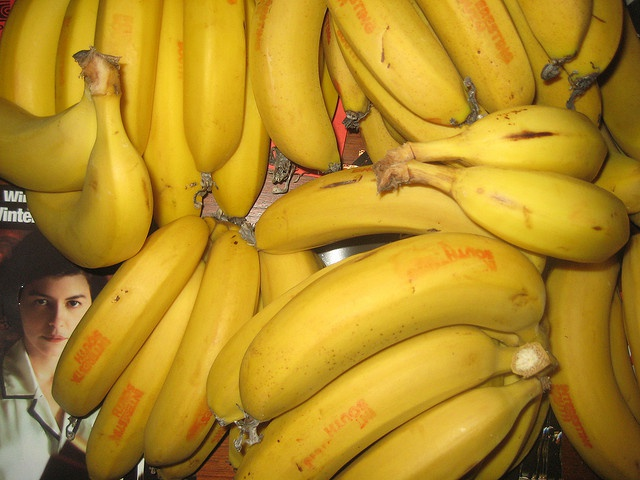Describe the objects in this image and their specific colors. I can see banana in maroon, orange, olive, and gold tones, banana in maroon, gold, and olive tones, banana in maroon, olive, and gold tones, banana in maroon and olive tones, and people in maroon, black, darkgray, and tan tones in this image. 